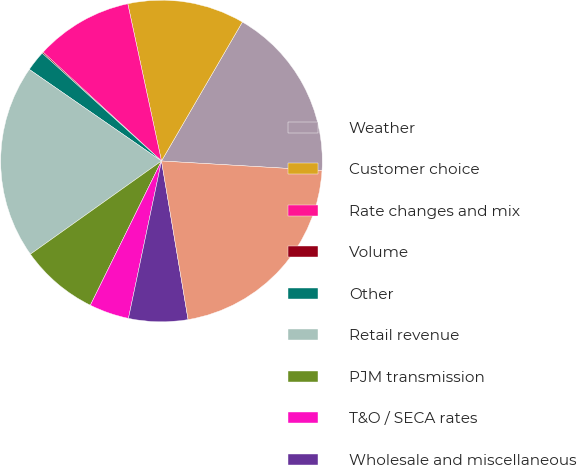Convert chart to OTSL. <chart><loc_0><loc_0><loc_500><loc_500><pie_chart><fcel>Weather<fcel>Customer choice<fcel>Rate changes and mix<fcel>Volume<fcel>Other<fcel>Retail revenue<fcel>PJM transmission<fcel>T&O / SECA rates<fcel>Wholesale and miscellaneous<fcel>Increase in operating revenues<nl><fcel>17.55%<fcel>11.75%<fcel>9.81%<fcel>0.13%<fcel>2.06%<fcel>19.48%<fcel>7.87%<fcel>4.0%<fcel>5.94%<fcel>21.42%<nl></chart> 